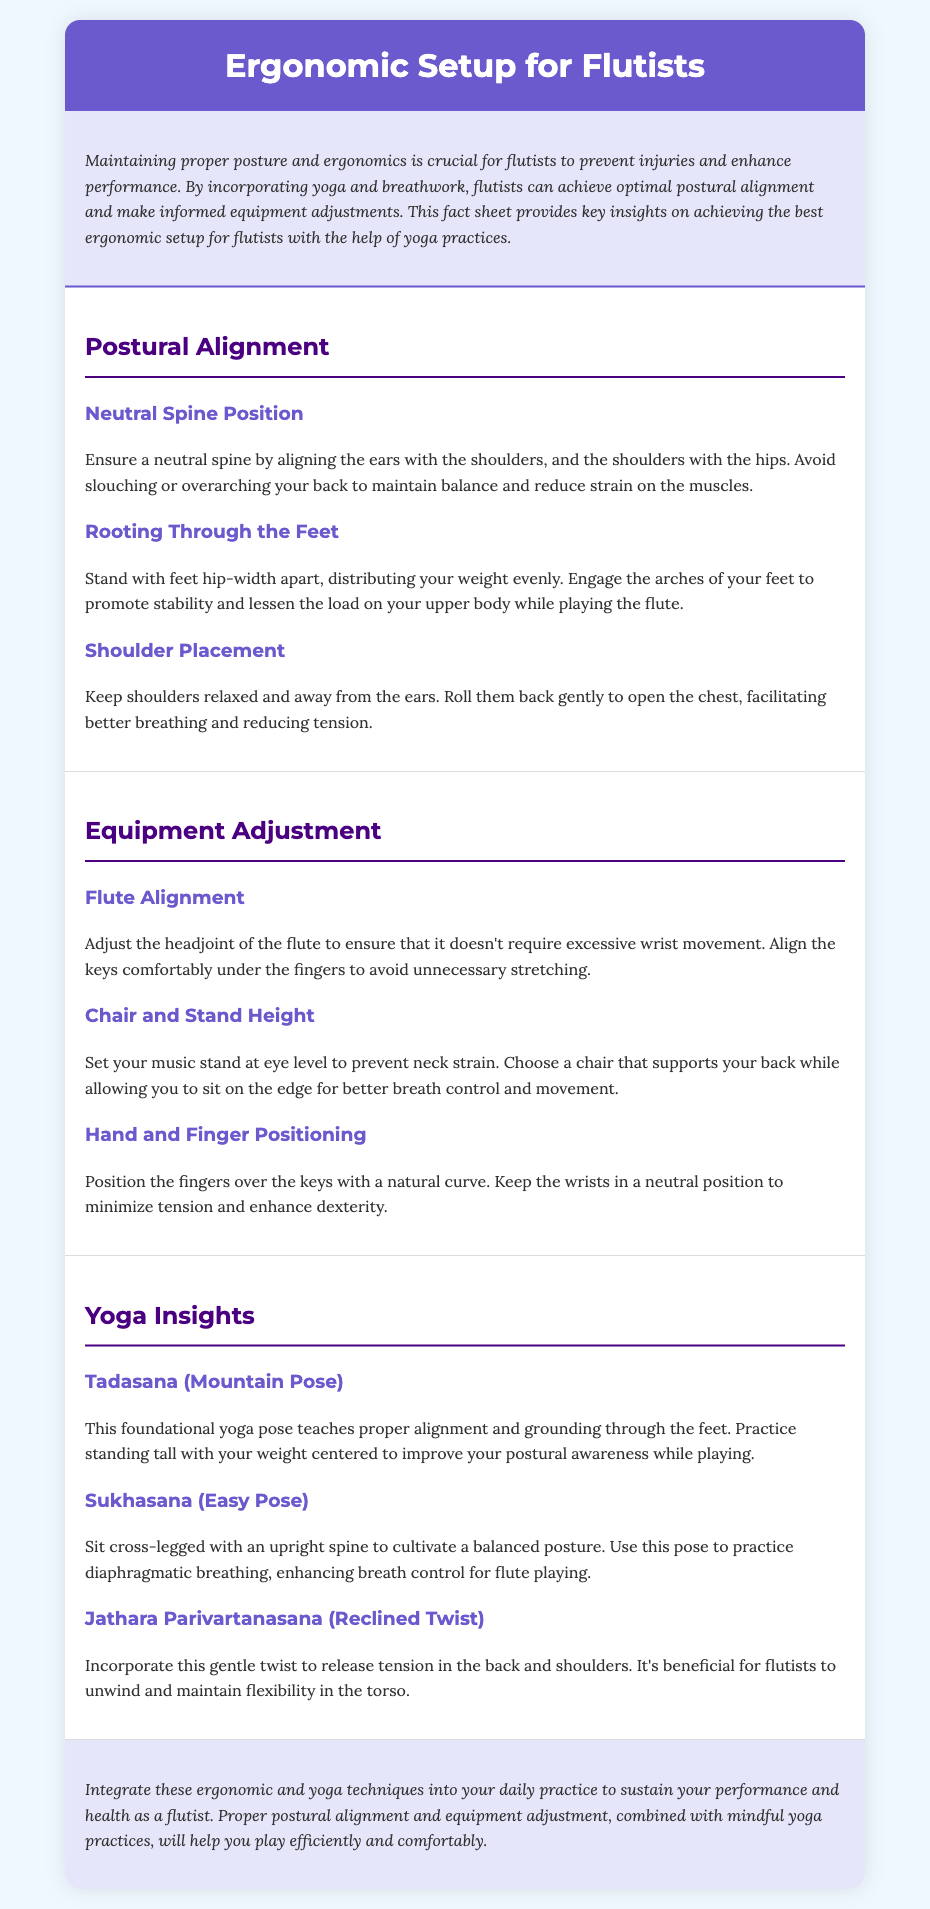What is the purpose of the fact sheet? The purpose of the fact sheet is to provide key insights on achieving the best ergonomic setup for flutists with the help of yoga practices.
Answer: To provide key insights on achieving the best ergonomic setup for flutists with the help of yoga practices What is the first section about? The first section is titled "Postural Alignment" and discusses the importance of proper posture for flutists.
Answer: Postural Alignment What should be maintained for a neutral spine position? A neutral spine position requires aligning the ears with the shoulders and the shoulders with the hips.
Answer: Ears with shoulders, shoulders with hips What pose helps improve postural awareness while playing? Tadasana (Mountain Pose) is mentioned as a foundational pose to help improve postural awareness.
Answer: Tadasana (Mountain Pose) How should the music stand be set? The music stand should be set at eye level to prevent neck strain.
Answer: At eye level Which pose is suggested for practicing diaphragmatic breathing? Sukhasana (Easy Pose) is recommended for practicing diaphragmatic breathing.
Answer: Sukhasana (Easy Pose) What should fingers do when positioned over keys? Fingers should have a natural curve when positioned over the keys.
Answer: Have a natural curve Which technique reduces tension in the back and shoulders? Jathara Parivartanasana (Reclined Twist) is suggested for releasing tension in the back and shoulders.
Answer: Jathara Parivartanasana (Reclined Twist) What is a major benefit of yoga practices for flutists? Yoga practices help flutists sustain their performance and health.
Answer: Sustain performance and health 